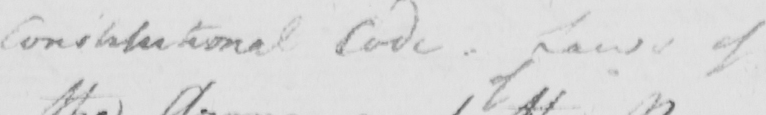Transcribe the text shown in this historical manuscript line. Constitutional Code - Laws ofof 